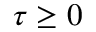<formula> <loc_0><loc_0><loc_500><loc_500>\tau \geq 0</formula> 